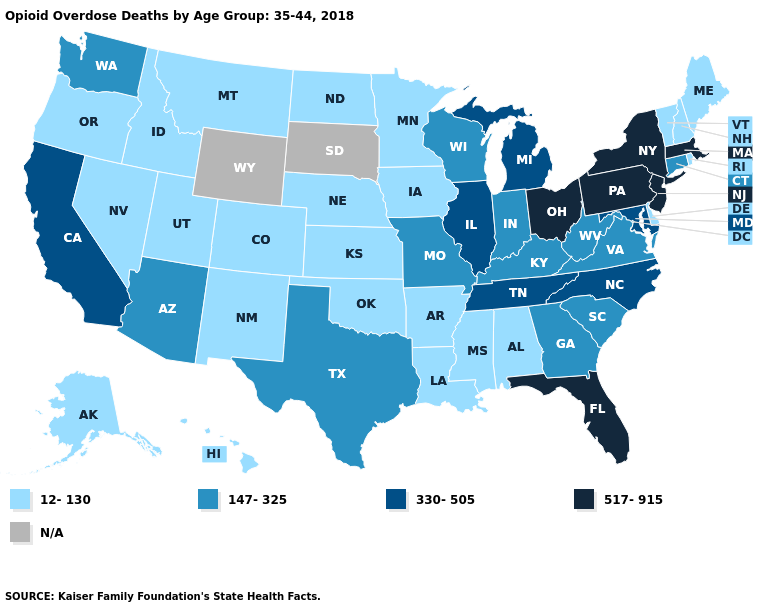What is the value of Vermont?
Be succinct. 12-130. Does the first symbol in the legend represent the smallest category?
Short answer required. Yes. What is the value of Iowa?
Write a very short answer. 12-130. Which states have the highest value in the USA?
Be succinct. Florida, Massachusetts, New Jersey, New York, Ohio, Pennsylvania. Does New Jersey have the highest value in the USA?
Answer briefly. Yes. What is the value of Minnesota?
Write a very short answer. 12-130. Among the states that border Wisconsin , which have the highest value?
Short answer required. Illinois, Michigan. Does Idaho have the highest value in the USA?
Keep it brief. No. What is the value of Illinois?
Write a very short answer. 330-505. What is the lowest value in the MidWest?
Short answer required. 12-130. Name the states that have a value in the range 517-915?
Answer briefly. Florida, Massachusetts, New Jersey, New York, Ohio, Pennsylvania. What is the value of Louisiana?
Concise answer only. 12-130. What is the value of South Dakota?
Give a very brief answer. N/A. What is the lowest value in states that border Texas?
Keep it brief. 12-130. 